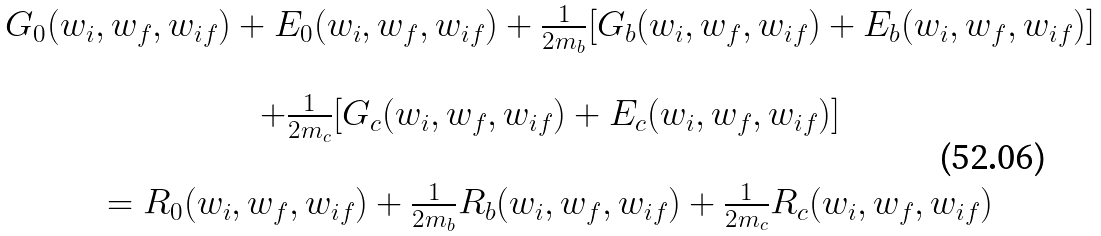<formula> <loc_0><loc_0><loc_500><loc_500>\begin{array} { c } G _ { 0 } ( w _ { i } , w _ { f } , w _ { i f } ) + E _ { 0 } ( w _ { i } , w _ { f } , w _ { i f } ) + \frac { 1 } { 2 m _ { b } } [ G _ { b } ( w _ { i } , w _ { f } , w _ { i f } ) + E _ { b } ( w _ { i } , w _ { f } , w _ { i f } ) ] \\ \\ + \frac { 1 } { 2 m _ { c } } [ G _ { c } ( w _ { i } , w _ { f } , w _ { i f } ) + E _ { c } ( w _ { i } , w _ { f } , w _ { i f } ) ] \\ \\ = R _ { 0 } ( w _ { i } , w _ { f } , w _ { i f } ) + \frac { 1 } { 2 m _ { b } } R _ { b } ( w _ { i } , w _ { f } , w _ { i f } ) + \frac { 1 } { 2 m _ { c } } R _ { c } ( w _ { i } , w _ { f } , w _ { i f } ) \end{array}</formula> 